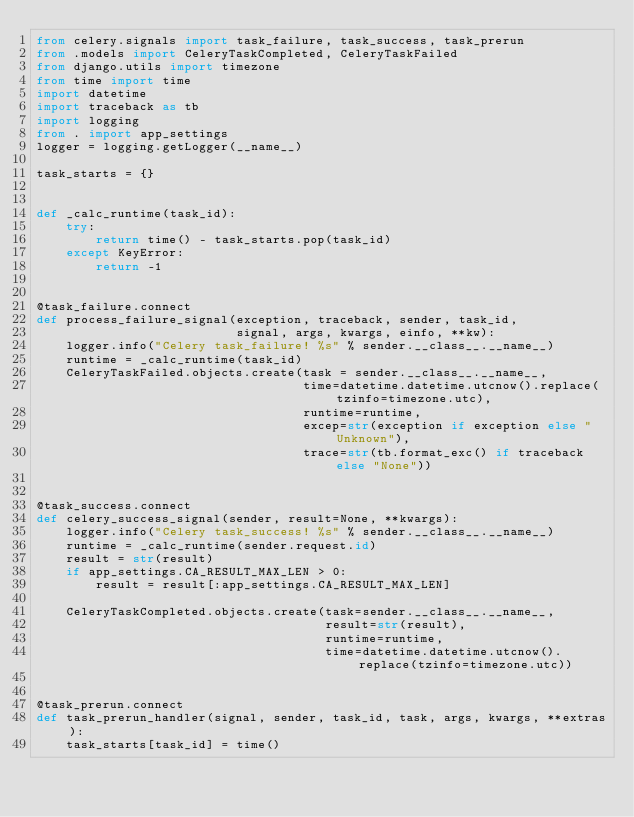Convert code to text. <code><loc_0><loc_0><loc_500><loc_500><_Python_>from celery.signals import task_failure, task_success, task_prerun
from .models import CeleryTaskCompleted, CeleryTaskFailed
from django.utils import timezone
from time import time
import datetime
import traceback as tb
import logging
from . import app_settings
logger = logging.getLogger(__name__)

task_starts = {}


def _calc_runtime(task_id):
    try:
        return time() - task_starts.pop(task_id)
    except KeyError:
        return -1


@task_failure.connect
def process_failure_signal(exception, traceback, sender, task_id,
                           signal, args, kwargs, einfo, **kw):
    logger.info("Celery task_failure! %s" % sender.__class__.__name__)
    runtime = _calc_runtime(task_id)
    CeleryTaskFailed.objects.create(task = sender.__class__.__name__,
                                    time=datetime.datetime.utcnow().replace(tzinfo=timezone.utc),
                                    runtime=runtime,
                                    excep=str(exception if exception else "Unknown"),
                                    trace=str(tb.format_exc() if traceback else "None"))


@task_success.connect
def celery_success_signal(sender, result=None, **kwargs):
    logger.info("Celery task_success! %s" % sender.__class__.__name__)
    runtime = _calc_runtime(sender.request.id)
    result = str(result)
    if app_settings.CA_RESULT_MAX_LEN > 0:
        result = result[:app_settings.CA_RESULT_MAX_LEN]
        
    CeleryTaskCompleted.objects.create(task=sender.__class__.__name__,
                                       result=str(result),
                                       runtime=runtime,
                                       time=datetime.datetime.utcnow().replace(tzinfo=timezone.utc))


@task_prerun.connect
def task_prerun_handler(signal, sender, task_id, task, args, kwargs, **extras):
    task_starts[task_id] = time()
</code> 